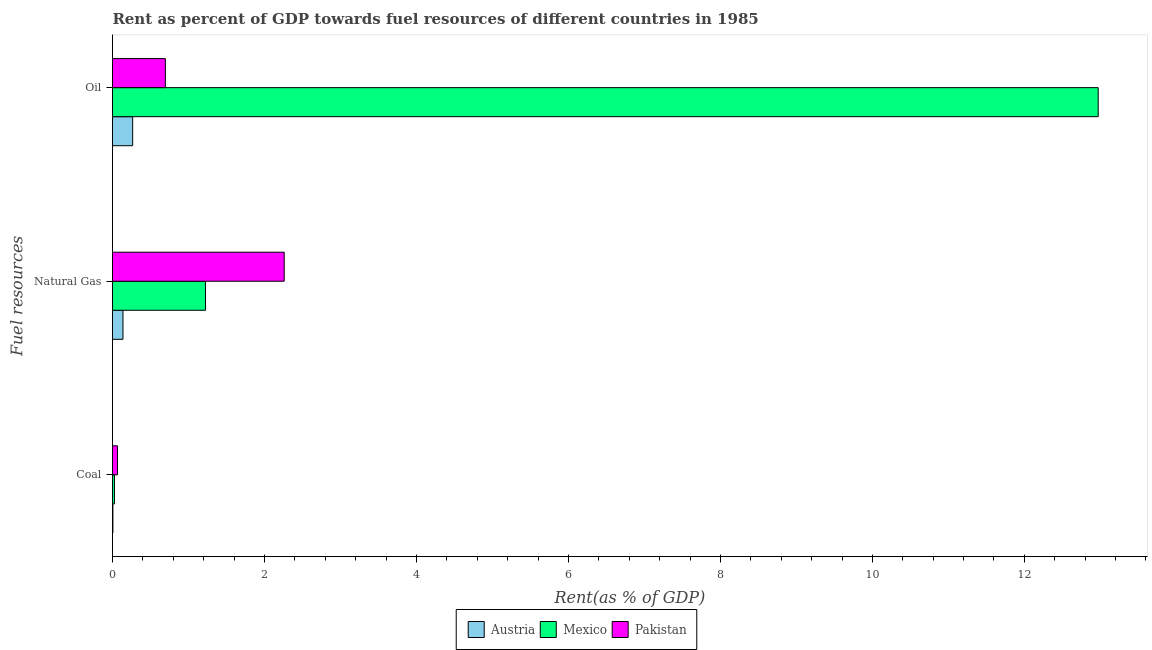Are the number of bars per tick equal to the number of legend labels?
Provide a short and direct response. Yes. How many bars are there on the 3rd tick from the top?
Your response must be concise. 3. What is the label of the 2nd group of bars from the top?
Provide a succinct answer. Natural Gas. What is the rent towards natural gas in Mexico?
Provide a short and direct response. 1.22. Across all countries, what is the maximum rent towards coal?
Offer a very short reply. 0.07. Across all countries, what is the minimum rent towards oil?
Give a very brief answer. 0.27. In which country was the rent towards oil maximum?
Your answer should be compact. Mexico. What is the total rent towards coal in the graph?
Your response must be concise. 0.1. What is the difference between the rent towards coal in Austria and that in Pakistan?
Offer a very short reply. -0.06. What is the difference between the rent towards natural gas in Pakistan and the rent towards oil in Austria?
Keep it short and to the point. 1.99. What is the average rent towards oil per country?
Your answer should be compact. 4.64. What is the difference between the rent towards natural gas and rent towards coal in Austria?
Offer a very short reply. 0.13. What is the ratio of the rent towards oil in Austria to that in Mexico?
Make the answer very short. 0.02. Is the rent towards natural gas in Pakistan less than that in Mexico?
Your response must be concise. No. What is the difference between the highest and the second highest rent towards natural gas?
Offer a terse response. 1.04. What is the difference between the highest and the lowest rent towards oil?
Provide a succinct answer. 12.71. In how many countries, is the rent towards oil greater than the average rent towards oil taken over all countries?
Your answer should be compact. 1. What does the 1st bar from the top in Oil represents?
Offer a terse response. Pakistan. What does the 2nd bar from the bottom in Coal represents?
Offer a very short reply. Mexico. Is it the case that in every country, the sum of the rent towards coal and rent towards natural gas is greater than the rent towards oil?
Provide a succinct answer. No. How many countries are there in the graph?
Give a very brief answer. 3. What is the difference between two consecutive major ticks on the X-axis?
Provide a succinct answer. 2. How are the legend labels stacked?
Your response must be concise. Horizontal. What is the title of the graph?
Provide a short and direct response. Rent as percent of GDP towards fuel resources of different countries in 1985. What is the label or title of the X-axis?
Keep it short and to the point. Rent(as % of GDP). What is the label or title of the Y-axis?
Provide a short and direct response. Fuel resources. What is the Rent(as % of GDP) of Austria in Coal?
Give a very brief answer. 0.01. What is the Rent(as % of GDP) of Mexico in Coal?
Ensure brevity in your answer.  0.03. What is the Rent(as % of GDP) of Pakistan in Coal?
Ensure brevity in your answer.  0.07. What is the Rent(as % of GDP) of Austria in Natural Gas?
Provide a succinct answer. 0.14. What is the Rent(as % of GDP) in Mexico in Natural Gas?
Provide a succinct answer. 1.22. What is the Rent(as % of GDP) in Pakistan in Natural Gas?
Give a very brief answer. 2.26. What is the Rent(as % of GDP) of Austria in Oil?
Offer a very short reply. 0.27. What is the Rent(as % of GDP) of Mexico in Oil?
Give a very brief answer. 12.97. What is the Rent(as % of GDP) in Pakistan in Oil?
Ensure brevity in your answer.  0.7. Across all Fuel resources, what is the maximum Rent(as % of GDP) in Austria?
Provide a short and direct response. 0.27. Across all Fuel resources, what is the maximum Rent(as % of GDP) in Mexico?
Provide a succinct answer. 12.97. Across all Fuel resources, what is the maximum Rent(as % of GDP) of Pakistan?
Your response must be concise. 2.26. Across all Fuel resources, what is the minimum Rent(as % of GDP) in Austria?
Offer a very short reply. 0.01. Across all Fuel resources, what is the minimum Rent(as % of GDP) of Mexico?
Your answer should be compact. 0.03. Across all Fuel resources, what is the minimum Rent(as % of GDP) of Pakistan?
Your response must be concise. 0.07. What is the total Rent(as % of GDP) in Austria in the graph?
Your response must be concise. 0.41. What is the total Rent(as % of GDP) of Mexico in the graph?
Your answer should be very brief. 14.22. What is the total Rent(as % of GDP) of Pakistan in the graph?
Your response must be concise. 3.02. What is the difference between the Rent(as % of GDP) of Austria in Coal and that in Natural Gas?
Your answer should be very brief. -0.13. What is the difference between the Rent(as % of GDP) of Mexico in Coal and that in Natural Gas?
Give a very brief answer. -1.2. What is the difference between the Rent(as % of GDP) in Pakistan in Coal and that in Natural Gas?
Provide a succinct answer. -2.19. What is the difference between the Rent(as % of GDP) in Austria in Coal and that in Oil?
Offer a terse response. -0.26. What is the difference between the Rent(as % of GDP) of Mexico in Coal and that in Oil?
Your answer should be very brief. -12.95. What is the difference between the Rent(as % of GDP) in Pakistan in Coal and that in Oil?
Your answer should be very brief. -0.63. What is the difference between the Rent(as % of GDP) in Austria in Natural Gas and that in Oil?
Offer a very short reply. -0.13. What is the difference between the Rent(as % of GDP) in Mexico in Natural Gas and that in Oil?
Keep it short and to the point. -11.75. What is the difference between the Rent(as % of GDP) of Pakistan in Natural Gas and that in Oil?
Ensure brevity in your answer.  1.56. What is the difference between the Rent(as % of GDP) of Austria in Coal and the Rent(as % of GDP) of Mexico in Natural Gas?
Offer a very short reply. -1.22. What is the difference between the Rent(as % of GDP) of Austria in Coal and the Rent(as % of GDP) of Pakistan in Natural Gas?
Provide a short and direct response. -2.25. What is the difference between the Rent(as % of GDP) of Mexico in Coal and the Rent(as % of GDP) of Pakistan in Natural Gas?
Offer a very short reply. -2.23. What is the difference between the Rent(as % of GDP) in Austria in Coal and the Rent(as % of GDP) in Mexico in Oil?
Provide a succinct answer. -12.97. What is the difference between the Rent(as % of GDP) of Austria in Coal and the Rent(as % of GDP) of Pakistan in Oil?
Make the answer very short. -0.69. What is the difference between the Rent(as % of GDP) of Mexico in Coal and the Rent(as % of GDP) of Pakistan in Oil?
Provide a succinct answer. -0.67. What is the difference between the Rent(as % of GDP) of Austria in Natural Gas and the Rent(as % of GDP) of Mexico in Oil?
Make the answer very short. -12.83. What is the difference between the Rent(as % of GDP) of Austria in Natural Gas and the Rent(as % of GDP) of Pakistan in Oil?
Keep it short and to the point. -0.56. What is the difference between the Rent(as % of GDP) in Mexico in Natural Gas and the Rent(as % of GDP) in Pakistan in Oil?
Provide a short and direct response. 0.53. What is the average Rent(as % of GDP) of Austria per Fuel resources?
Keep it short and to the point. 0.14. What is the average Rent(as % of GDP) in Mexico per Fuel resources?
Your answer should be very brief. 4.74. What is the average Rent(as % of GDP) in Pakistan per Fuel resources?
Make the answer very short. 1.01. What is the difference between the Rent(as % of GDP) of Austria and Rent(as % of GDP) of Mexico in Coal?
Your answer should be very brief. -0.02. What is the difference between the Rent(as % of GDP) in Austria and Rent(as % of GDP) in Pakistan in Coal?
Give a very brief answer. -0.06. What is the difference between the Rent(as % of GDP) in Mexico and Rent(as % of GDP) in Pakistan in Coal?
Your answer should be very brief. -0.04. What is the difference between the Rent(as % of GDP) of Austria and Rent(as % of GDP) of Mexico in Natural Gas?
Ensure brevity in your answer.  -1.09. What is the difference between the Rent(as % of GDP) in Austria and Rent(as % of GDP) in Pakistan in Natural Gas?
Your answer should be compact. -2.12. What is the difference between the Rent(as % of GDP) of Mexico and Rent(as % of GDP) of Pakistan in Natural Gas?
Keep it short and to the point. -1.04. What is the difference between the Rent(as % of GDP) of Austria and Rent(as % of GDP) of Mexico in Oil?
Give a very brief answer. -12.71. What is the difference between the Rent(as % of GDP) of Austria and Rent(as % of GDP) of Pakistan in Oil?
Your answer should be very brief. -0.43. What is the difference between the Rent(as % of GDP) in Mexico and Rent(as % of GDP) in Pakistan in Oil?
Offer a terse response. 12.28. What is the ratio of the Rent(as % of GDP) of Austria in Coal to that in Natural Gas?
Provide a short and direct response. 0.04. What is the ratio of the Rent(as % of GDP) in Mexico in Coal to that in Natural Gas?
Provide a short and direct response. 0.02. What is the ratio of the Rent(as % of GDP) of Pakistan in Coal to that in Natural Gas?
Keep it short and to the point. 0.03. What is the ratio of the Rent(as % of GDP) of Austria in Coal to that in Oil?
Your response must be concise. 0.02. What is the ratio of the Rent(as % of GDP) of Mexico in Coal to that in Oil?
Offer a very short reply. 0. What is the ratio of the Rent(as % of GDP) in Pakistan in Coal to that in Oil?
Give a very brief answer. 0.1. What is the ratio of the Rent(as % of GDP) in Austria in Natural Gas to that in Oil?
Provide a short and direct response. 0.52. What is the ratio of the Rent(as % of GDP) in Mexico in Natural Gas to that in Oil?
Keep it short and to the point. 0.09. What is the ratio of the Rent(as % of GDP) of Pakistan in Natural Gas to that in Oil?
Make the answer very short. 3.25. What is the difference between the highest and the second highest Rent(as % of GDP) of Austria?
Provide a succinct answer. 0.13. What is the difference between the highest and the second highest Rent(as % of GDP) of Mexico?
Your answer should be very brief. 11.75. What is the difference between the highest and the second highest Rent(as % of GDP) in Pakistan?
Your answer should be very brief. 1.56. What is the difference between the highest and the lowest Rent(as % of GDP) of Austria?
Your answer should be compact. 0.26. What is the difference between the highest and the lowest Rent(as % of GDP) of Mexico?
Provide a short and direct response. 12.95. What is the difference between the highest and the lowest Rent(as % of GDP) of Pakistan?
Your answer should be very brief. 2.19. 